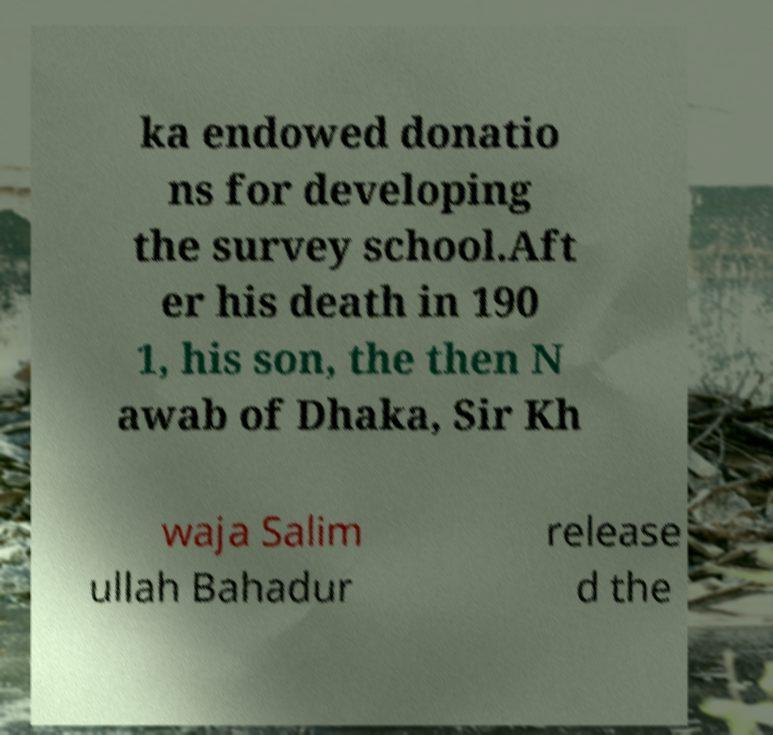I need the written content from this picture converted into text. Can you do that? ka endowed donatio ns for developing the survey school.Aft er his death in 190 1, his son, the then N awab of Dhaka, Sir Kh waja Salim ullah Bahadur release d the 